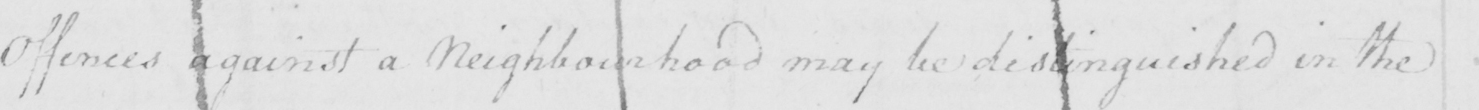What does this handwritten line say? Offences against a Neighbourhood may be distinguished in the 